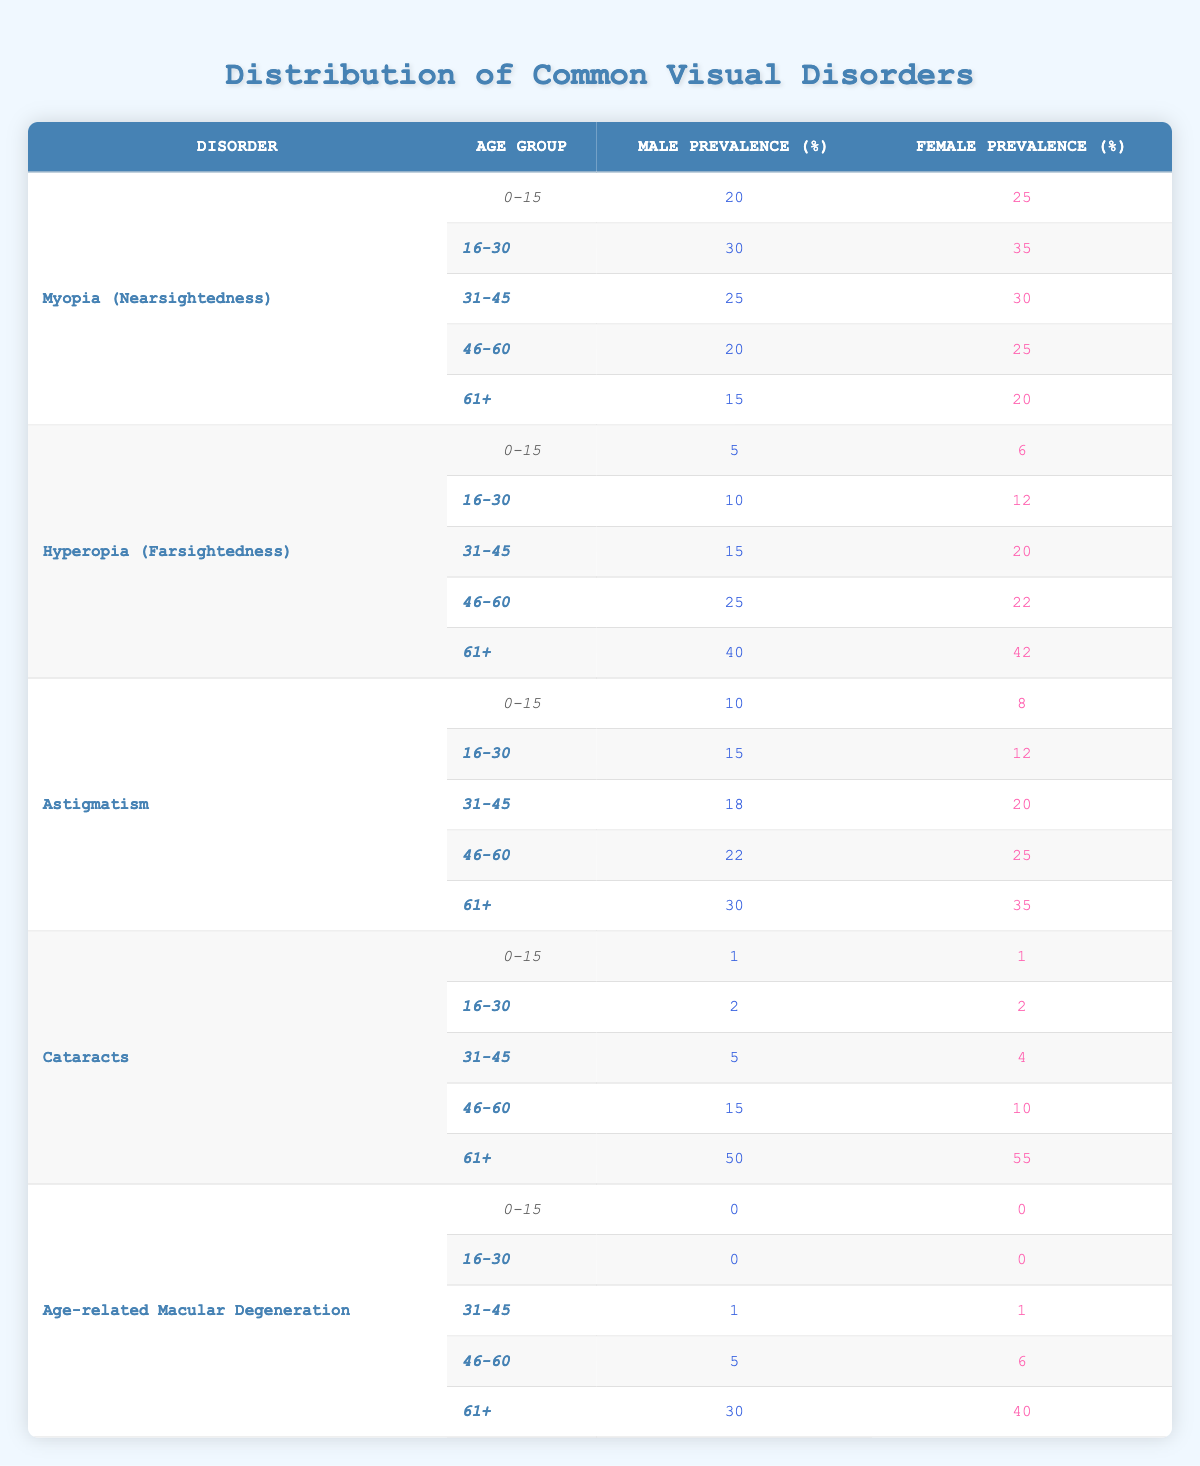What is the male prevalence of Myopia for the age group 31-45? From the table, under Myopia (Nearsightedness), the row for the age group 31-45 shows a male prevalence of 25%.
Answer: 25 What is the female prevalence of Cataracts in the age group 61+? Looking at the table, under Cataracts, for the age group 61+, the female prevalence is noted as 55%.
Answer: 55 Which visual disorder shows the highest male prevalence in the age group 61+? In the table under the age group 61+, the disorder "Cataracts" has the highest male prevalence of 50%, more than any other disorder for that age group.
Answer: Cataracts What is the average male prevalence of Astigmatism across all age groups? Summing the male prevalence for Astigmatism across all age groups: 10 + 15 + 18 + 22 + 30 = 95. There are 5 age groups, so the average is 95 / 5 = 19.
Answer: 19 Is the female prevalence of Hyperopia greater than the female prevalence of Myopia in the age group 46-60? For the age group 46-60, the female prevalence of Hyperopia is 22%, while for Myopia, it is 25%. Therefore, the female prevalence of Myopia is greater.
Answer: No What is the total male prevalence of visual disorders for the age group 0-15? For the age group 0-15, we add the male prevalence from the disorders: Myopia (20) + Hyperopia (5) + Astigmatism (10) + Cataracts (1) + Age-related Macular Degeneration (0) = 36.
Answer: 36 Which gender shows a higher prevalence of Age-related Macular Degeneration in the age group 61+? In the age group 61+, the male prevalence is 30% and the female prevalence is 40%. Thus, females show a higher prevalence.
Answer: Female What is the difference in prevalence between male and female for Astigmatism in the age group 46-60? In the age group 46-60 for Astigmatism, the male prevalence is 22% and the female prevalence is 25%. The difference is 25 - 22 = 3%.
Answer: 3 How many visual disorders have a male prevalence of over 20% for the age group 46-60? For the age group 46-60, we assess each disorder: Myopia (20%), Hyperopia (25%), Astigmatism (22%), Cataracts (15%), and Age-related Macular Degeneration (5%). Three disorders (Hyperopia, Astigmatism) have male prevalences over 20%.
Answer: 3 